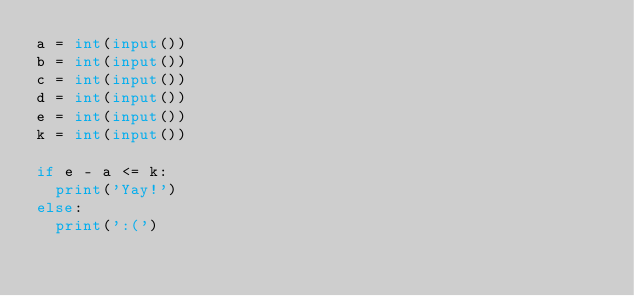Convert code to text. <code><loc_0><loc_0><loc_500><loc_500><_Python_>a = int(input())
b = int(input())
c = int(input())
d = int(input())
e = int(input())
k = int(input())

if e - a <= k:
  print('Yay!')
else:
  print(':(')</code> 